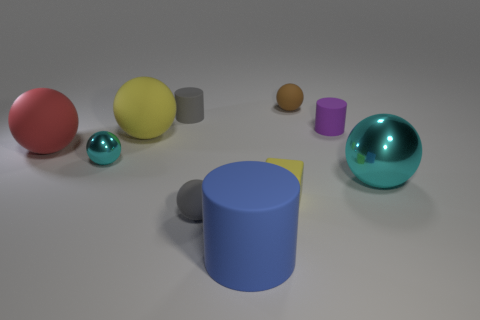Subtract all brown balls. How many balls are left? 5 Subtract all gray spheres. How many spheres are left? 5 Subtract all brown spheres. Subtract all red cubes. How many spheres are left? 5 Subtract all cylinders. How many objects are left? 7 Subtract all blue cubes. Subtract all brown rubber objects. How many objects are left? 9 Add 1 brown rubber objects. How many brown rubber objects are left? 2 Add 7 brown balls. How many brown balls exist? 8 Subtract 1 yellow blocks. How many objects are left? 9 